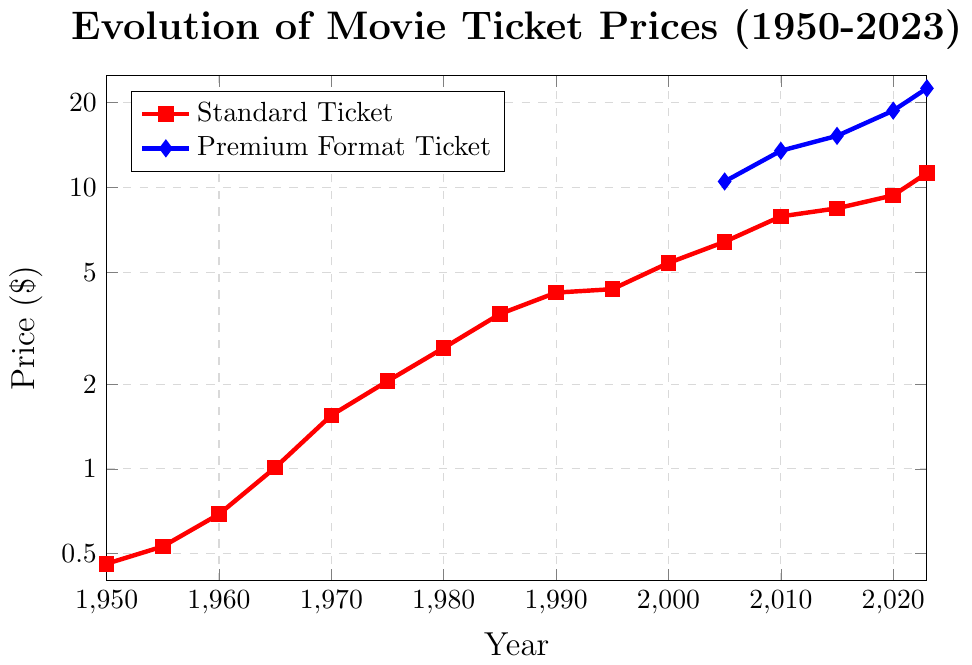What is the ticket price for a standard movie in 1990? Check the red line for standard ticket prices and locate the value at 1990.
Answer: $4.23 How much did the premium format ticket price increase from 2010 to 2023? Find the blue line for premium formats, note the prices in 2010 ($13.50) and 2023 ($22.50). Calculate the difference: $22.50 - $13.50 = $9.00.
Answer: $9.00 Which type of ticket had a higher price in 2005, standard or premium format? Compare the red line for standard tickets ($6.41) and the blue line for premium format tickets ($10.50) at 2005.
Answer: Premium format By what factor did the standard ticket price increase from 1950 to 2023? Note the standard ticket prices in 1950 ($0.46) and 2023 ($11.25). Compute the factor: $11.25 / $0.46 ≈ 24.46.
Answer: ~24.46 What is the trend in standard ticket prices from 1950 to 2023? Observe the red line pattern; it shows a steady upward trend from $0.46 in 1950 to $11.25 in 2023.
Answer: Increasing Which year shows the introduction of premium format ticket pricing? Locate the year in which the blue line for premium format tickets first appears, which is 2005.
Answer: 2005 How much did the premium format ticket price differ from the standard ticket price in 2020? Refer to the prices in 2020 for standard ($9.37) and premium format ($18.75). Calculate the difference: $18.75 - $9.37 = $9.38.
Answer: $9.38 What can be said about the growth rates of premium format tickets versus standard tickets from 2005 to 2023? Observe the slopes of both lines from 2005 to 2023. The blue line (premium) reveals a steeper increase compared to the red line (standard), indicating a higher growth rate for premium formats.
Answer: Premium formats grew faster What was the standard ticket price in 1985 and how does it compare to the price in 2023? Find the red line price in 1985 ($3.55) and compare it to the 2023 price ($11.25). The 2023 price is $11.25 - $3.55 = $7.70 higher.
Answer: $7.70 higher What is the average price of a standard ticket from 2000 to 2023? Calculate the average of the given standard ticket prices from 2000 ($5.39), 2005 ($6.41), 2010 ($7.89), 2015 ($8.43), 2020 ($9.37), to 2023 ($11.25). Sum: $5.39 + $6.41 + $7.89 + $8.43 + $9.37 + $11.25 = $48.74. Average: $48.74 / 6 ≈ $8.12.
Answer: ~$8.12 